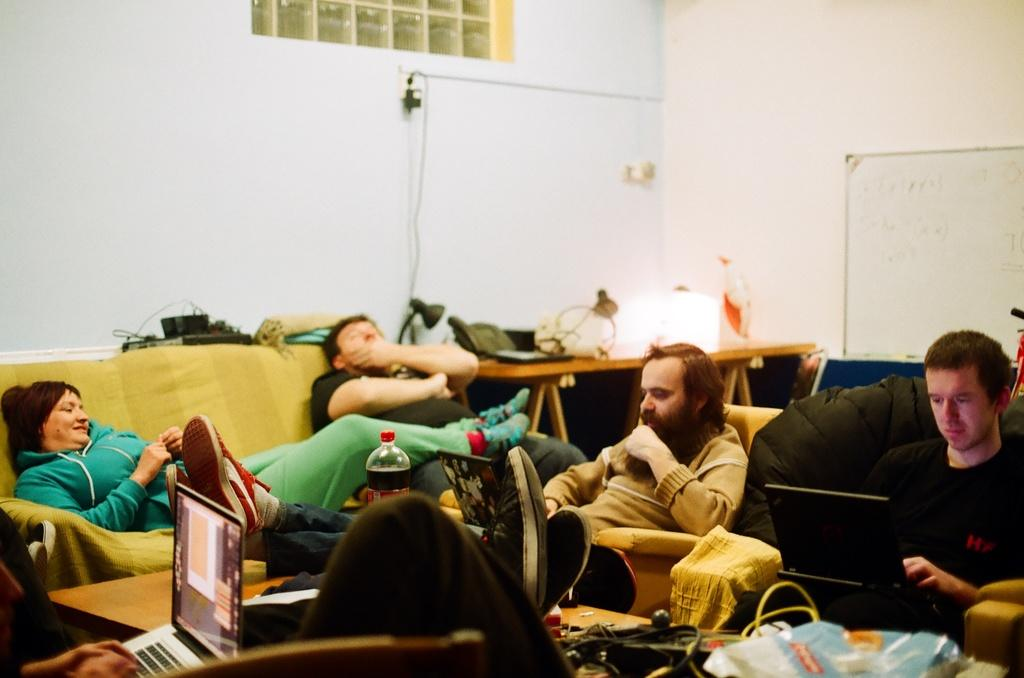What are the people in the image doing? There is a group of people sitting in the image. What electronic devices can be seen in the image? There are laptops visible in the image. What piece of furniture is present in the image? There is a table in the image. What objects are present in the image? There are some objects in the image. What can be seen in the background of the image? There is a board and a wall in the background of the image, along with a few things visible. Can you see a bike in the image? There is no bike present in the image. Are there any mountains visible in the background of the image? There are no mountains visible in the image; only a board, wall, and a few other things can be seen in the background. 